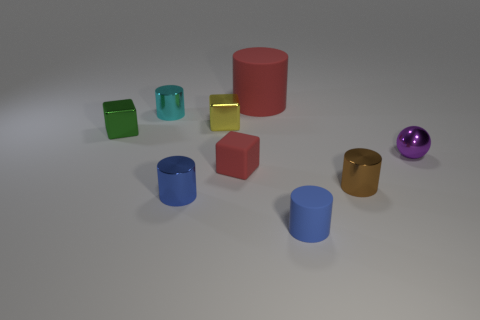Is the number of shiny blocks that are behind the cyan thing greater than the number of blue rubber things that are behind the tiny red matte cube?
Your response must be concise. No. The rubber cube that is the same color as the large cylinder is what size?
Provide a succinct answer. Small. Is the size of the ball the same as the rubber cylinder behind the small brown shiny object?
Offer a very short reply. No. What number of cylinders are small green things or small rubber things?
Offer a terse response. 1. What size is the other red thing that is made of the same material as the large red object?
Provide a succinct answer. Small. There is a metallic cube behind the green metal thing; is it the same size as the red thing behind the purple metal ball?
Provide a succinct answer. No. What number of things are either tiny rubber cubes or big purple matte balls?
Provide a short and direct response. 1. What is the shape of the brown metal thing?
Make the answer very short. Cylinder. What size is the red matte thing that is the same shape as the blue shiny thing?
Offer a very short reply. Large. There is a metal cylinder that is behind the red thing in front of the large rubber cylinder; how big is it?
Give a very brief answer. Small. 